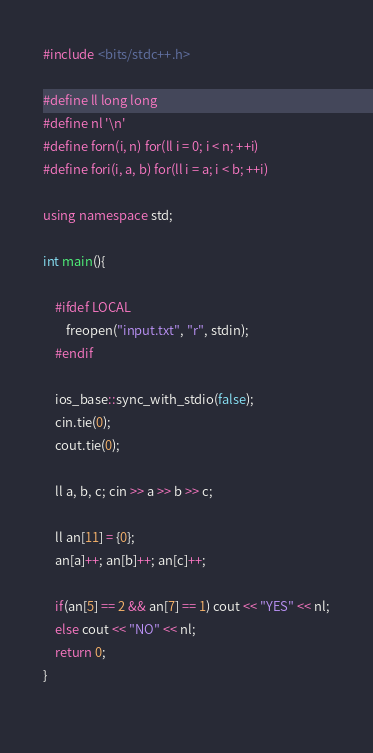<code> <loc_0><loc_0><loc_500><loc_500><_C++_>#include <bits/stdc++.h>

#define ll long long
#define nl '\n'
#define forn(i, n) for(ll i = 0; i < n; ++i)
#define fori(i, a, b) for(ll i = a; i < b; ++i)

using namespace std;

int main(){

    #ifdef LOCAL  
        freopen("input.txt", "r", stdin);
    #endif
    
    ios_base::sync_with_stdio(false);
    cin.tie(0);
    cout.tie(0);

    ll a, b, c; cin >> a >> b >> c;

    ll an[11] = {0};
    an[a]++; an[b]++; an[c]++;

    if(an[5] == 2 && an[7] == 1) cout << "YES" << nl;
    else cout << "NO" << nl;
    return 0;
}	
    </code> 